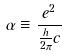<formula> <loc_0><loc_0><loc_500><loc_500>\alpha \equiv \frac { e ^ { 2 } } { \frac { h } { 2 \pi } c }</formula> 